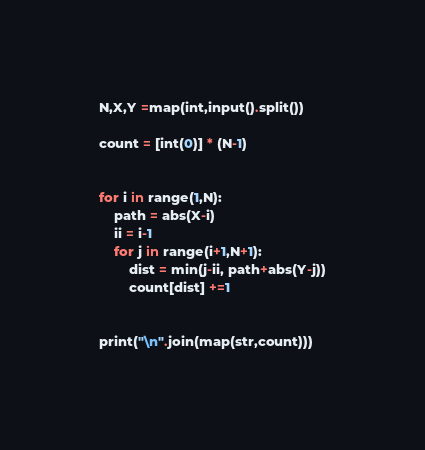Convert code to text. <code><loc_0><loc_0><loc_500><loc_500><_Python_>N,X,Y =map(int,input().split())

count = [int(0)] * (N-1)


for i in range(1,N):
    path = abs(X-i) 
    ii = i-1
    for j in range(i+1,N+1):
        dist = min(j-ii, path+abs(Y-j))
        count[dist] +=1


print("\n".join(map(str,count)))</code> 